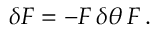<formula> <loc_0><loc_0><loc_500><loc_500>\delta F = - F \, \delta \theta \, F \, .</formula> 